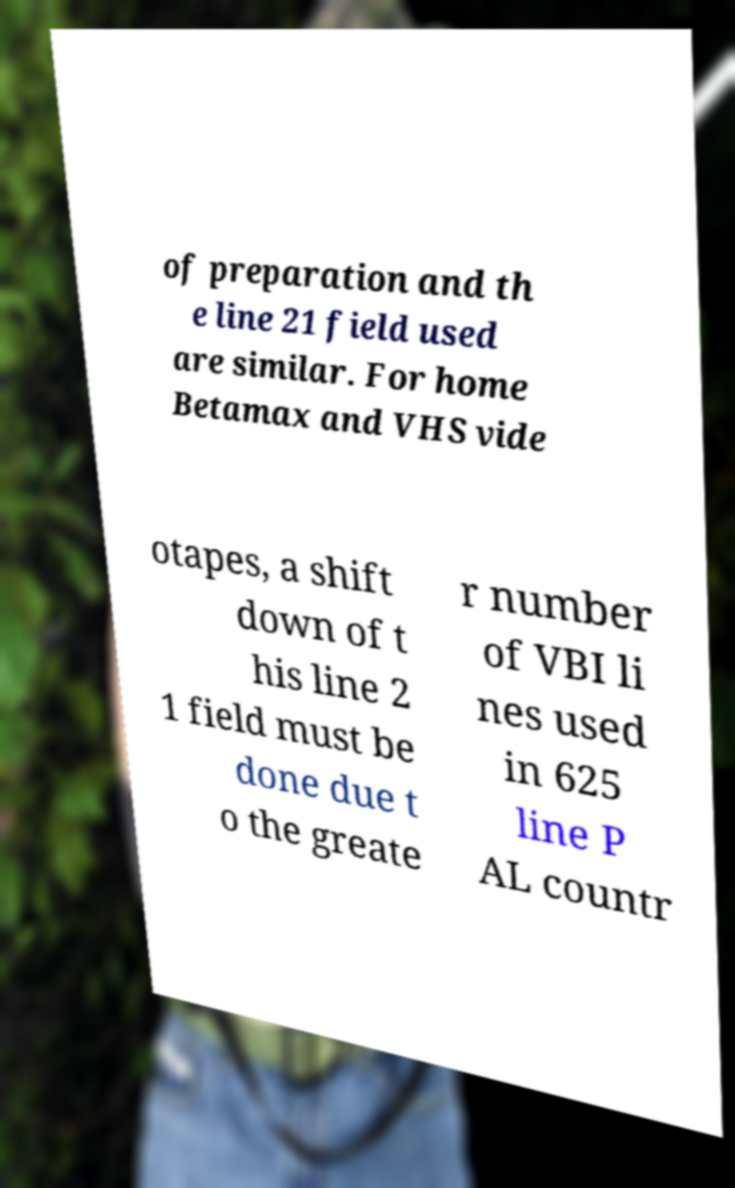Can you accurately transcribe the text from the provided image for me? of preparation and th e line 21 field used are similar. For home Betamax and VHS vide otapes, a shift down of t his line 2 1 field must be done due t o the greate r number of VBI li nes used in 625 line P AL countr 